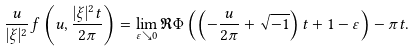Convert formula to latex. <formula><loc_0><loc_0><loc_500><loc_500>\frac { u } { | \xi | ^ { 2 } } f \left ( u , \frac { | \xi | ^ { 2 } t } { 2 \pi } \right ) = \lim _ { \varepsilon \searrow 0 } \Re \Phi \left ( \left ( - \frac { u } { 2 \pi } + \sqrt { - 1 } \right ) t + 1 - \varepsilon \right ) - \pi t .</formula> 